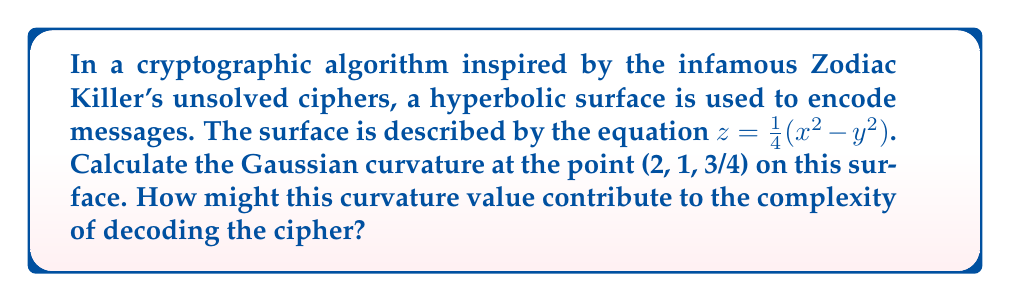Help me with this question. To find the Gaussian curvature of the hyperbolic surface, we'll follow these steps:

1) The surface is given by $z = \frac{1}{4}(x^2 - y^2)$. Let's define $f(x,y) = \frac{1}{4}(x^2 - y^2)$.

2) Calculate the partial derivatives:
   $f_x = \frac{\partial f}{\partial x} = \frac{1}{2}x$
   $f_y = \frac{\partial f}{\partial y} = -\frac{1}{2}y$
   $f_{xx} = \frac{\partial^2 f}{\partial x^2} = \frac{1}{2}$
   $f_{yy} = \frac{\partial^2 f}{\partial y^2} = -\frac{1}{2}$
   $f_{xy} = f_{yx} = \frac{\partial^2 f}{\partial x \partial y} = 0$

3) The Gaussian curvature K is given by:
   $$K = \frac{f_{xx}f_{yy} - f_{xy}^2}{(1 + f_x^2 + f_y^2)^2}$$

4) Substitute the values at the point (2, 1, 3/4):
   $$K = \frac{(\frac{1}{2})(-\frac{1}{2}) - 0^2}{(1 + (1)^2 + (-\frac{1}{2})^2)^2}$$

5) Simplify:
   $$K = \frac{-\frac{1}{4}}{(1 + 1 + \frac{1}{4})^2} = \frac{-\frac{1}{4}}{(\frac{9}{4})^2} = -\frac{1}{4} \cdot \frac{16}{81} = -\frac{1}{81}$$

The negative curvature at this point indicates that the surface is saddle-shaped, which could contribute to the complexity of the cipher by introducing non-linear transformations to the encoded message. This makes it more challenging for codebreakers to identify patterns or use linear cryptanalysis techniques.
Answer: $K = -\frac{1}{81}$ 